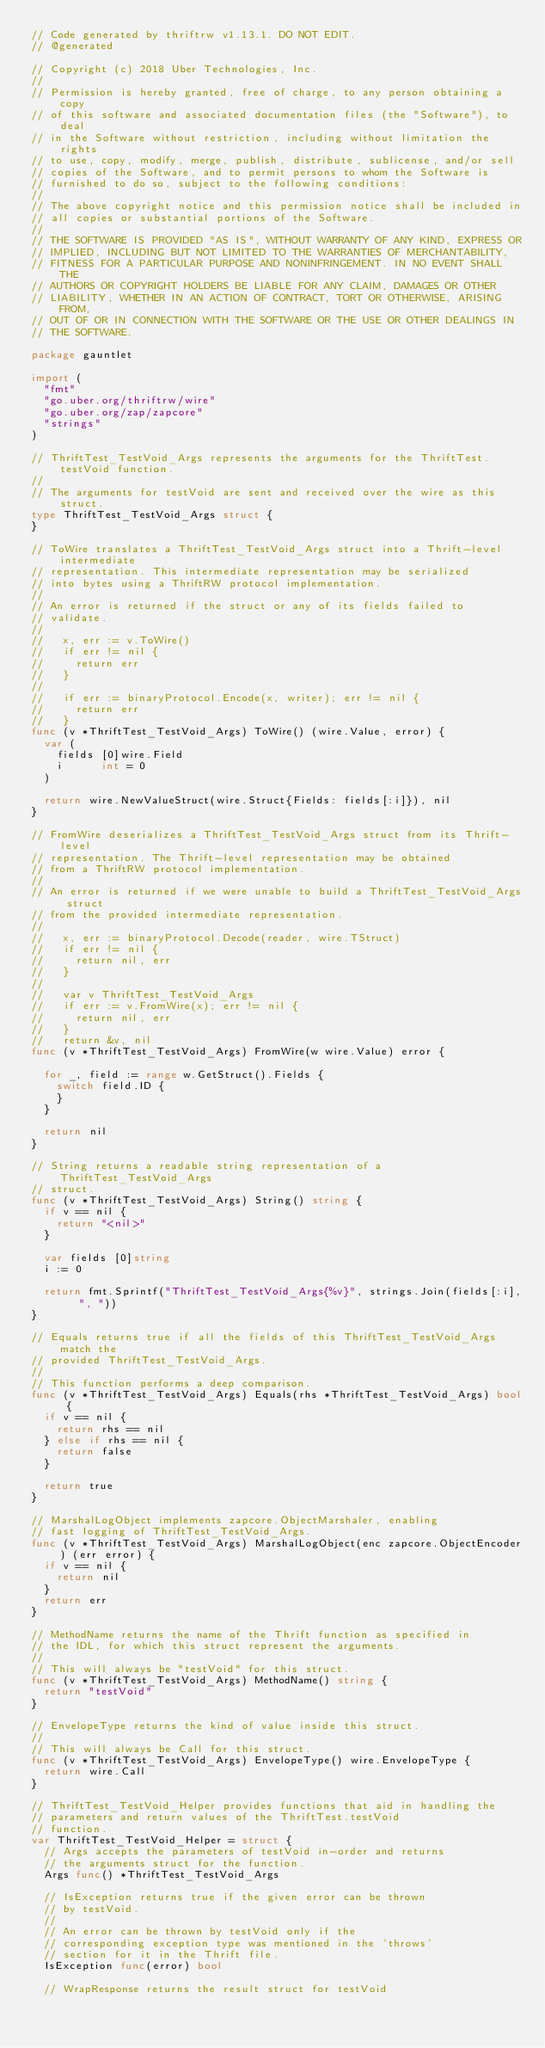Convert code to text. <code><loc_0><loc_0><loc_500><loc_500><_Go_>// Code generated by thriftrw v1.13.1. DO NOT EDIT.
// @generated

// Copyright (c) 2018 Uber Technologies, Inc.
//
// Permission is hereby granted, free of charge, to any person obtaining a copy
// of this software and associated documentation files (the "Software"), to deal
// in the Software without restriction, including without limitation the rights
// to use, copy, modify, merge, publish, distribute, sublicense, and/or sell
// copies of the Software, and to permit persons to whom the Software is
// furnished to do so, subject to the following conditions:
//
// The above copyright notice and this permission notice shall be included in
// all copies or substantial portions of the Software.
//
// THE SOFTWARE IS PROVIDED "AS IS", WITHOUT WARRANTY OF ANY KIND, EXPRESS OR
// IMPLIED, INCLUDING BUT NOT LIMITED TO THE WARRANTIES OF MERCHANTABILITY,
// FITNESS FOR A PARTICULAR PURPOSE AND NONINFRINGEMENT. IN NO EVENT SHALL THE
// AUTHORS OR COPYRIGHT HOLDERS BE LIABLE FOR ANY CLAIM, DAMAGES OR OTHER
// LIABILITY, WHETHER IN AN ACTION OF CONTRACT, TORT OR OTHERWISE, ARISING FROM,
// OUT OF OR IN CONNECTION WITH THE SOFTWARE OR THE USE OR OTHER DEALINGS IN
// THE SOFTWARE.

package gauntlet

import (
	"fmt"
	"go.uber.org/thriftrw/wire"
	"go.uber.org/zap/zapcore"
	"strings"
)

// ThriftTest_TestVoid_Args represents the arguments for the ThriftTest.testVoid function.
//
// The arguments for testVoid are sent and received over the wire as this struct.
type ThriftTest_TestVoid_Args struct {
}

// ToWire translates a ThriftTest_TestVoid_Args struct into a Thrift-level intermediate
// representation. This intermediate representation may be serialized
// into bytes using a ThriftRW protocol implementation.
//
// An error is returned if the struct or any of its fields failed to
// validate.
//
//   x, err := v.ToWire()
//   if err != nil {
//     return err
//   }
//
//   if err := binaryProtocol.Encode(x, writer); err != nil {
//     return err
//   }
func (v *ThriftTest_TestVoid_Args) ToWire() (wire.Value, error) {
	var (
		fields [0]wire.Field
		i      int = 0
	)

	return wire.NewValueStruct(wire.Struct{Fields: fields[:i]}), nil
}

// FromWire deserializes a ThriftTest_TestVoid_Args struct from its Thrift-level
// representation. The Thrift-level representation may be obtained
// from a ThriftRW protocol implementation.
//
// An error is returned if we were unable to build a ThriftTest_TestVoid_Args struct
// from the provided intermediate representation.
//
//   x, err := binaryProtocol.Decode(reader, wire.TStruct)
//   if err != nil {
//     return nil, err
//   }
//
//   var v ThriftTest_TestVoid_Args
//   if err := v.FromWire(x); err != nil {
//     return nil, err
//   }
//   return &v, nil
func (v *ThriftTest_TestVoid_Args) FromWire(w wire.Value) error {

	for _, field := range w.GetStruct().Fields {
		switch field.ID {
		}
	}

	return nil
}

// String returns a readable string representation of a ThriftTest_TestVoid_Args
// struct.
func (v *ThriftTest_TestVoid_Args) String() string {
	if v == nil {
		return "<nil>"
	}

	var fields [0]string
	i := 0

	return fmt.Sprintf("ThriftTest_TestVoid_Args{%v}", strings.Join(fields[:i], ", "))
}

// Equals returns true if all the fields of this ThriftTest_TestVoid_Args match the
// provided ThriftTest_TestVoid_Args.
//
// This function performs a deep comparison.
func (v *ThriftTest_TestVoid_Args) Equals(rhs *ThriftTest_TestVoid_Args) bool {
	if v == nil {
		return rhs == nil
	} else if rhs == nil {
		return false
	}

	return true
}

// MarshalLogObject implements zapcore.ObjectMarshaler, enabling
// fast logging of ThriftTest_TestVoid_Args.
func (v *ThriftTest_TestVoid_Args) MarshalLogObject(enc zapcore.ObjectEncoder) (err error) {
	if v == nil {
		return nil
	}
	return err
}

// MethodName returns the name of the Thrift function as specified in
// the IDL, for which this struct represent the arguments.
//
// This will always be "testVoid" for this struct.
func (v *ThriftTest_TestVoid_Args) MethodName() string {
	return "testVoid"
}

// EnvelopeType returns the kind of value inside this struct.
//
// This will always be Call for this struct.
func (v *ThriftTest_TestVoid_Args) EnvelopeType() wire.EnvelopeType {
	return wire.Call
}

// ThriftTest_TestVoid_Helper provides functions that aid in handling the
// parameters and return values of the ThriftTest.testVoid
// function.
var ThriftTest_TestVoid_Helper = struct {
	// Args accepts the parameters of testVoid in-order and returns
	// the arguments struct for the function.
	Args func() *ThriftTest_TestVoid_Args

	// IsException returns true if the given error can be thrown
	// by testVoid.
	//
	// An error can be thrown by testVoid only if the
	// corresponding exception type was mentioned in the 'throws'
	// section for it in the Thrift file.
	IsException func(error) bool

	// WrapResponse returns the result struct for testVoid</code> 